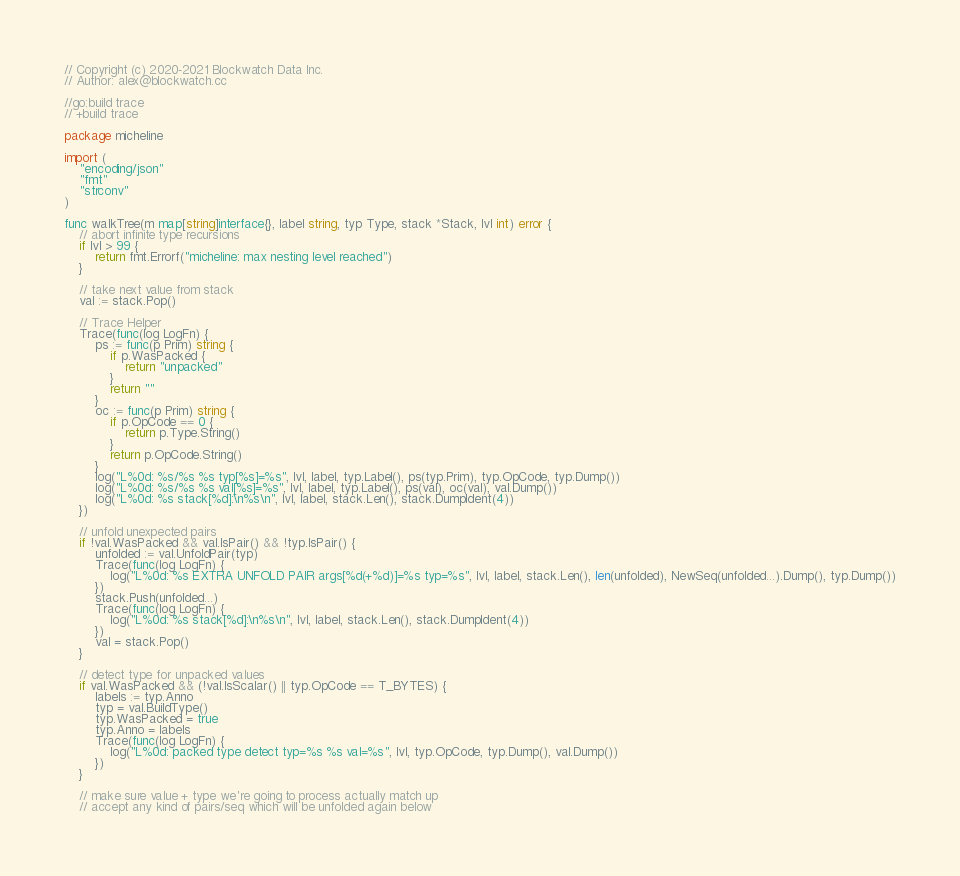Convert code to text. <code><loc_0><loc_0><loc_500><loc_500><_Go_>// Copyright (c) 2020-2021 Blockwatch Data Inc.
// Author: alex@blockwatch.cc

//go:build trace
// +build trace

package micheline

import (
    "encoding/json"
    "fmt"
    "strconv"
)

func walkTree(m map[string]interface{}, label string, typ Type, stack *Stack, lvl int) error {
    // abort infinite type recursions
    if lvl > 99 {
        return fmt.Errorf("micheline: max nesting level reached")
    }

    // take next value from stack
    val := stack.Pop()

    // Trace Helper
    Trace(func(log LogFn) {
        ps := func(p Prim) string {
            if p.WasPacked {
                return "unpacked"
            }
            return ""
        }
        oc := func(p Prim) string {
            if p.OpCode == 0 {
                return p.Type.String()
            }
            return p.OpCode.String()
        }
        log("L%0d: %s/%s %s typ[%s]=%s", lvl, label, typ.Label(), ps(typ.Prim), typ.OpCode, typ.Dump())
        log("L%0d: %s/%s %s val[%s]=%s", lvl, label, typ.Label(), ps(val), oc(val), val.Dump())
        log("L%0d: %s stack[%d]:\n%s\n", lvl, label, stack.Len(), stack.DumpIdent(4))
    })

    // unfold unexpected pairs
    if !val.WasPacked && val.IsPair() && !typ.IsPair() {
        unfolded := val.UnfoldPair(typ)
        Trace(func(log LogFn) {
            log("L%0d: %s EXTRA UNFOLD PAIR args[%d(+%d)]=%s typ=%s", lvl, label, stack.Len(), len(unfolded), NewSeq(unfolded...).Dump(), typ.Dump())
        })
        stack.Push(unfolded...)
        Trace(func(log LogFn) {
            log("L%0d: %s stack[%d]:\n%s\n", lvl, label, stack.Len(), stack.DumpIdent(4))
        })
        val = stack.Pop()
    }

    // detect type for unpacked values
    if val.WasPacked && (!val.IsScalar() || typ.OpCode == T_BYTES) {
        labels := typ.Anno
        typ = val.BuildType()
        typ.WasPacked = true
        typ.Anno = labels
        Trace(func(log LogFn) {
            log("L%0d: packed type detect typ=%s %s val=%s", lvl, typ.OpCode, typ.Dump(), val.Dump())
        })
    }

    // make sure value + type we're going to process actually match up
    // accept any kind of pairs/seq which will be unfolded again below</code> 